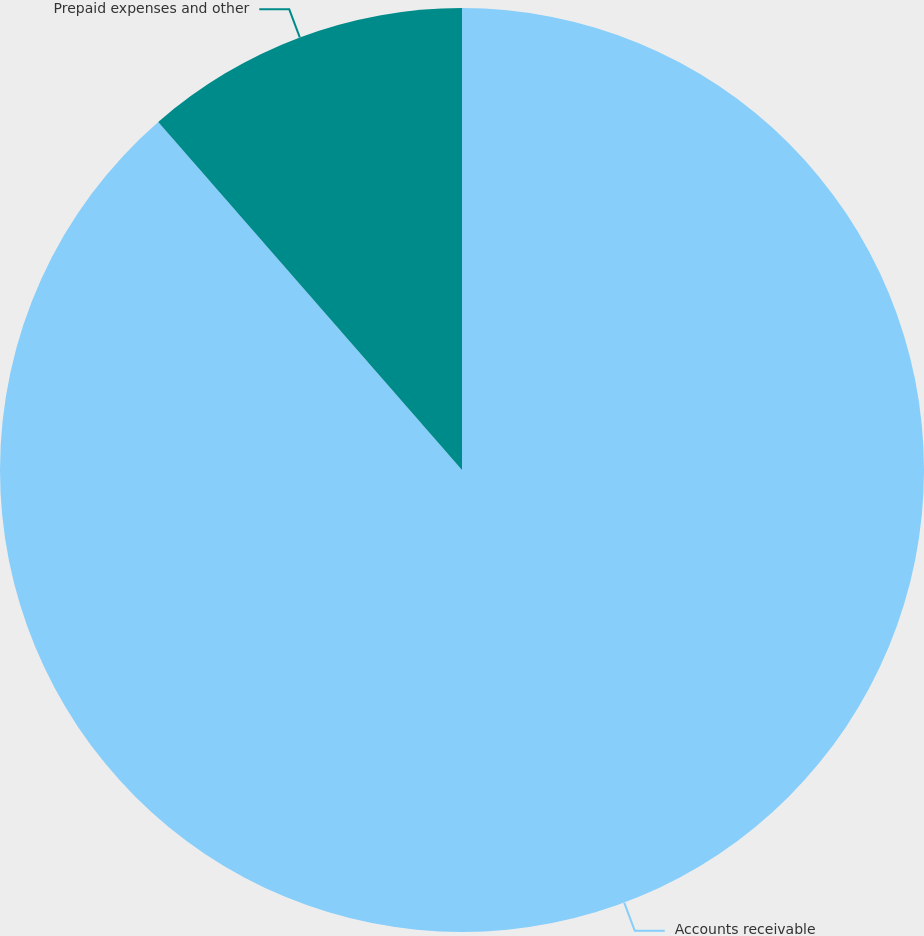<chart> <loc_0><loc_0><loc_500><loc_500><pie_chart><fcel>Accounts receivable<fcel>Prepaid expenses and other<nl><fcel>88.58%<fcel>11.42%<nl></chart> 